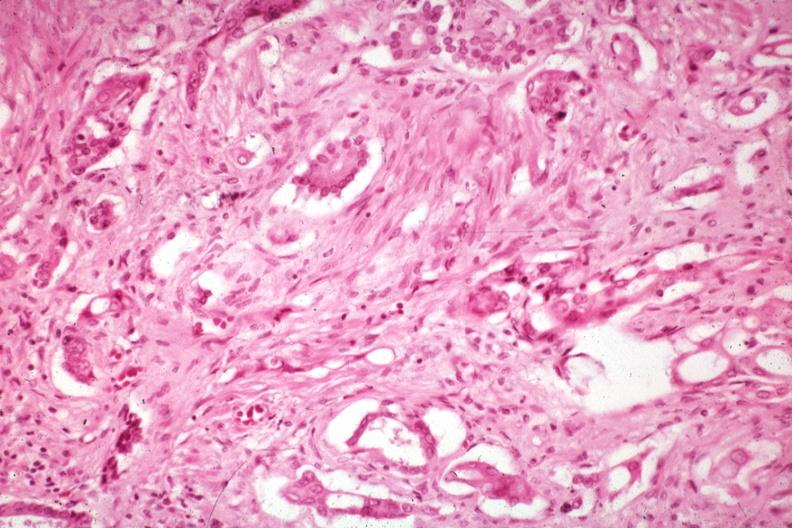how are anaplastic carcinoma with desmoplasia large myofibroblastic cell in the stroma?
Answer the question using a single word or phrase. Prominent 